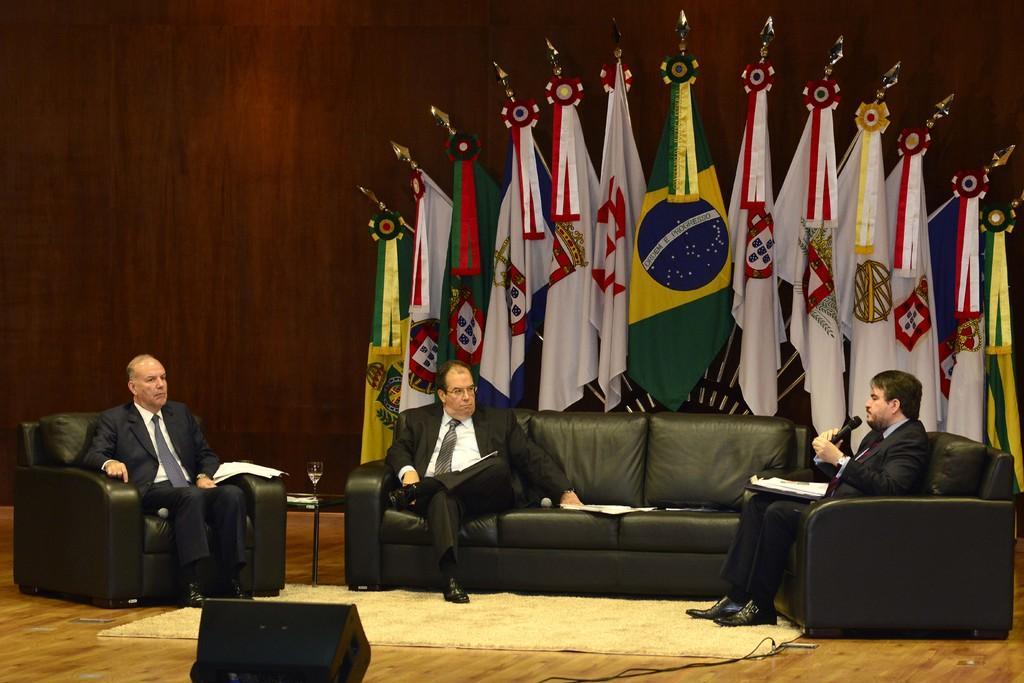In one or two sentences, can you explain what this image depicts? In this image there are three persons wearing black suits sitting on the couch and at the top of the image there are different national flags and at the bottom of the image there is a box. 